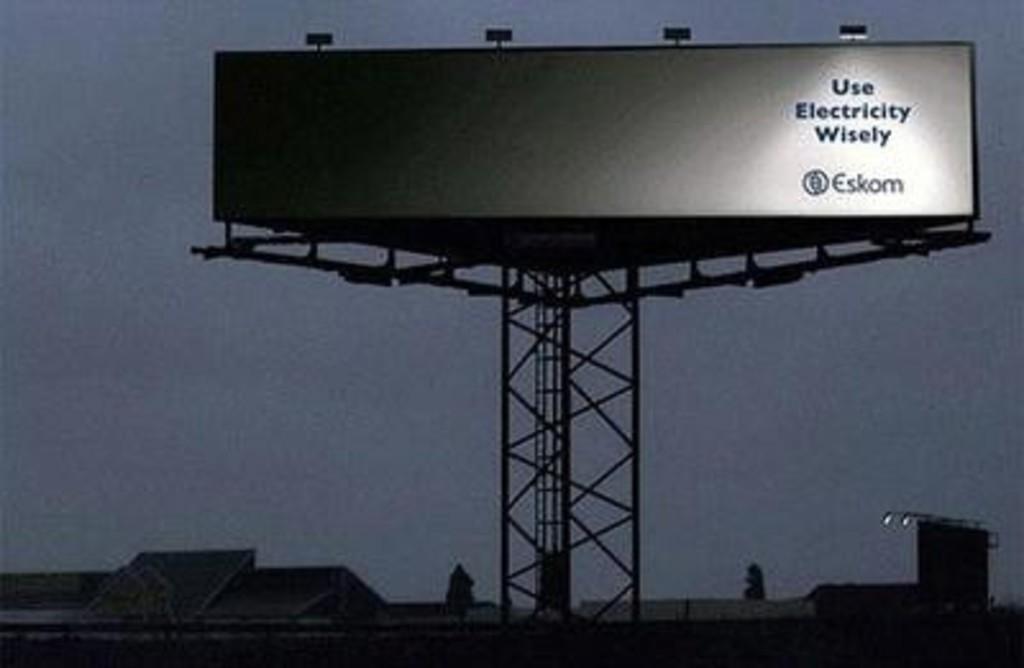How should you use electricity?
Make the answer very short. Wisely. What company is being advertised?
Make the answer very short. Eskom. 